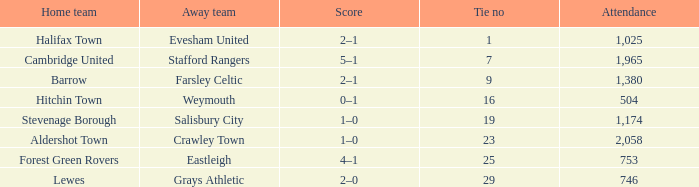Who was the away team in a tie no larger than 16 with forest green rovers at home? Eastleigh. 